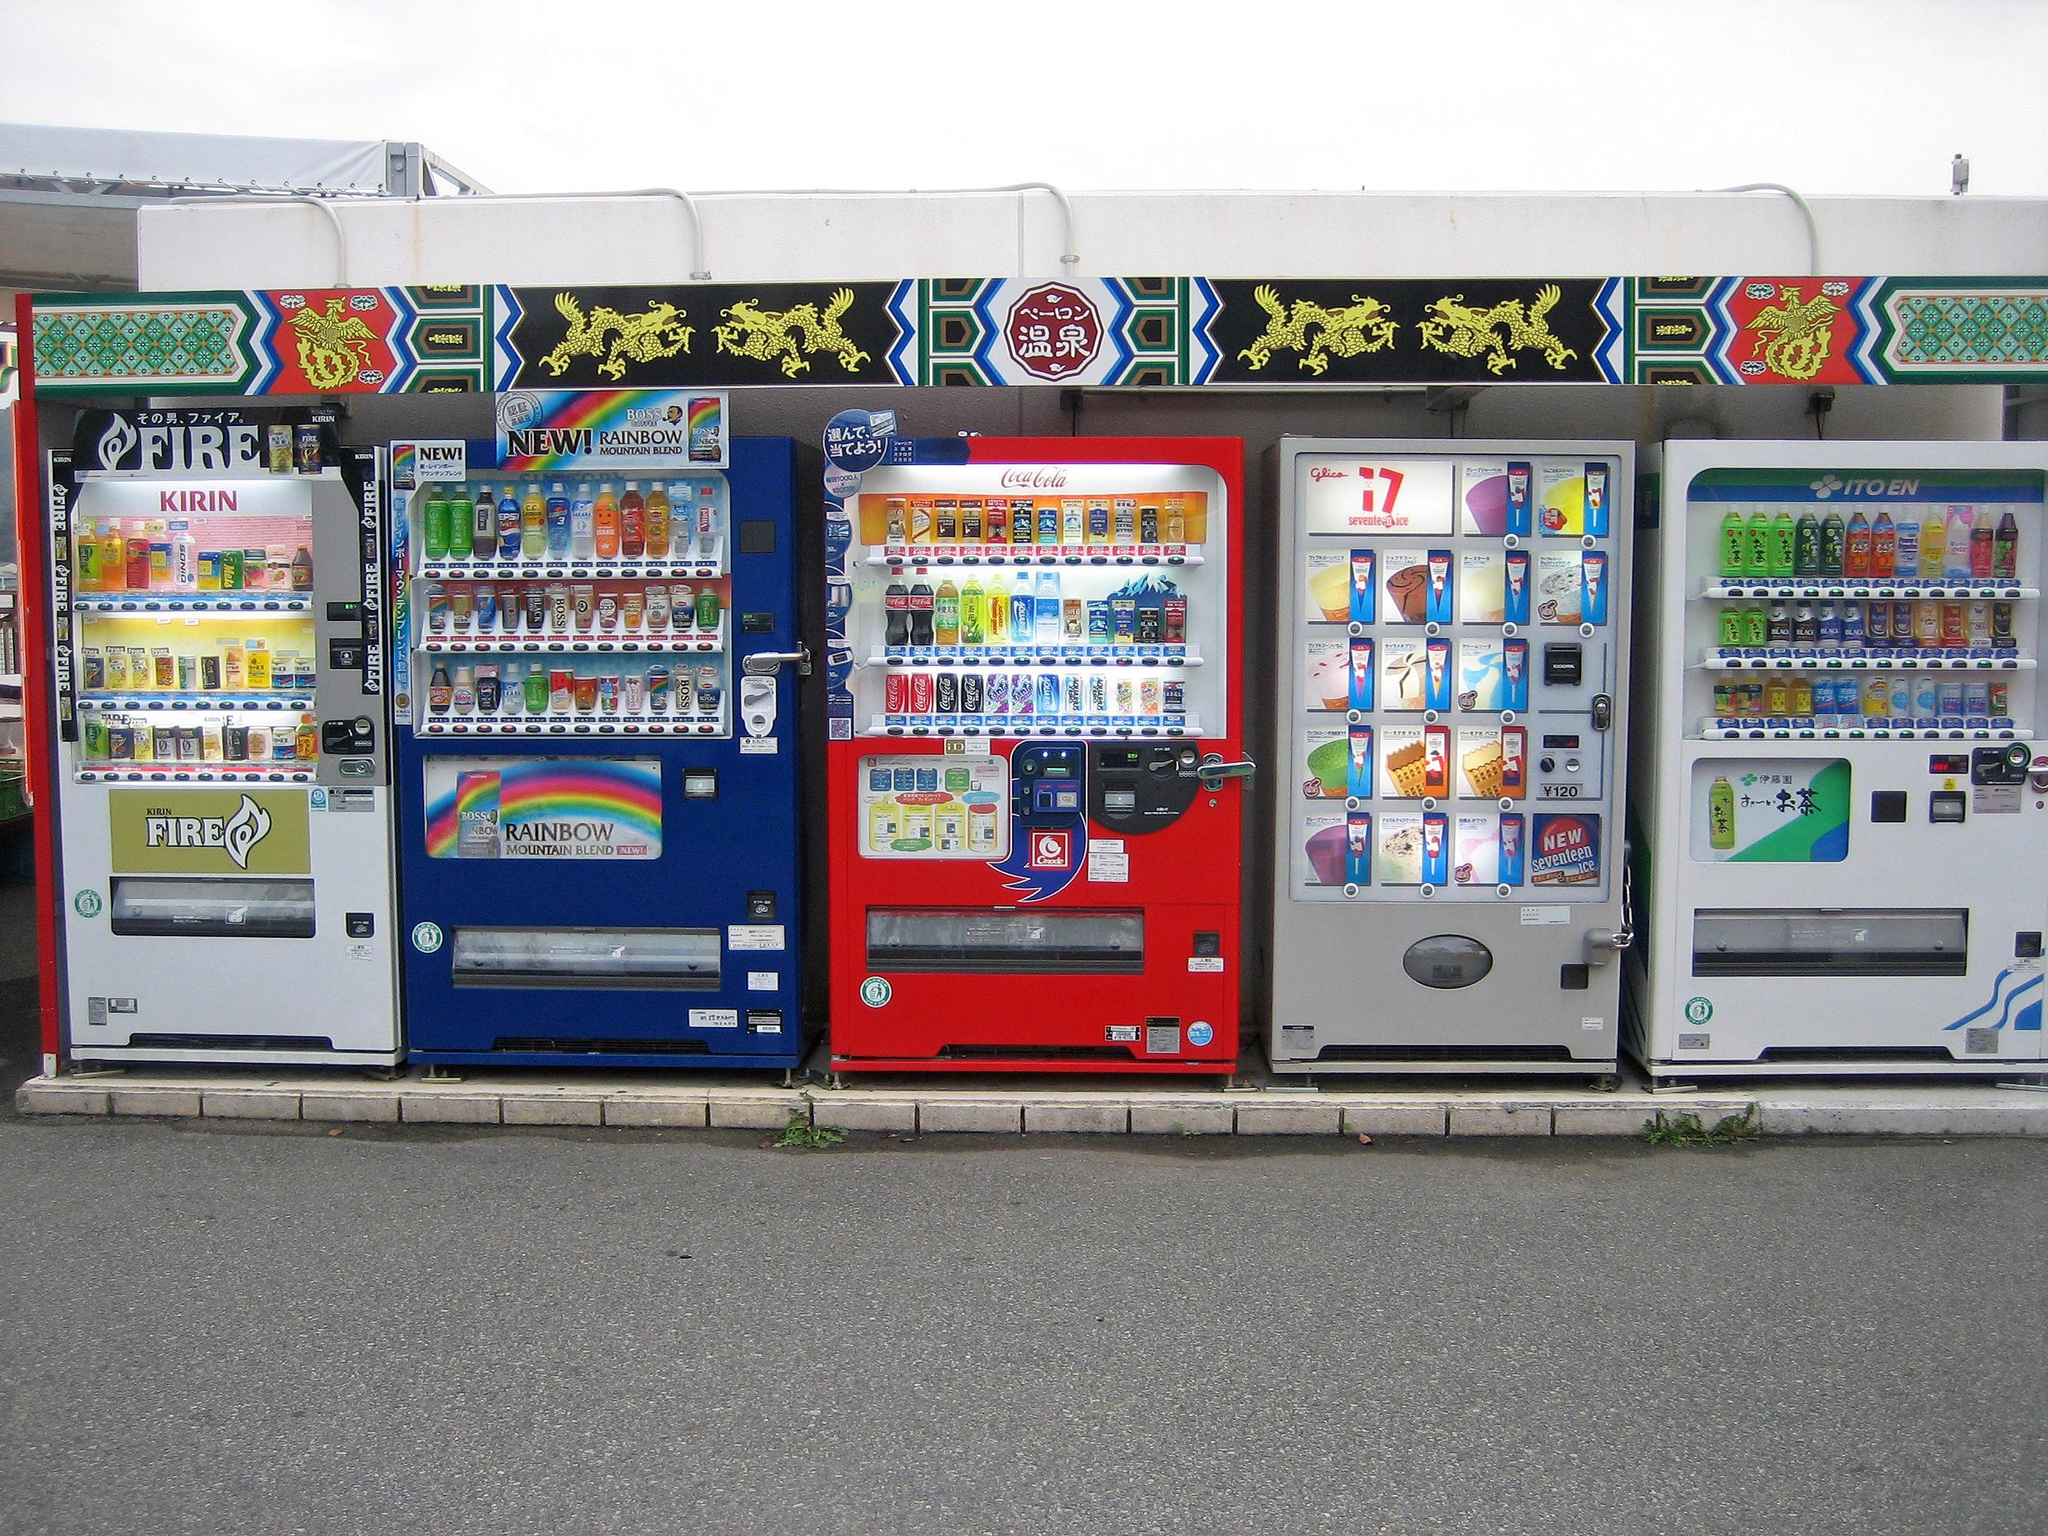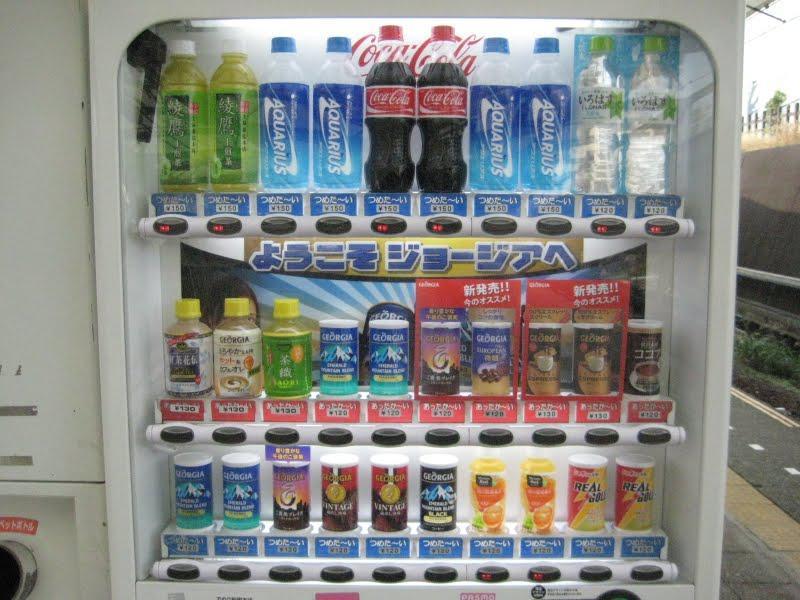The first image is the image on the left, the second image is the image on the right. For the images displayed, is the sentence "The image on the left features more than one vending machine." factually correct? Answer yes or no. Yes. The first image is the image on the left, the second image is the image on the right. Assess this claim about the two images: "An image shows the front of one vending machine, which is red and displays three rows of items.". Correct or not? Answer yes or no. No. 